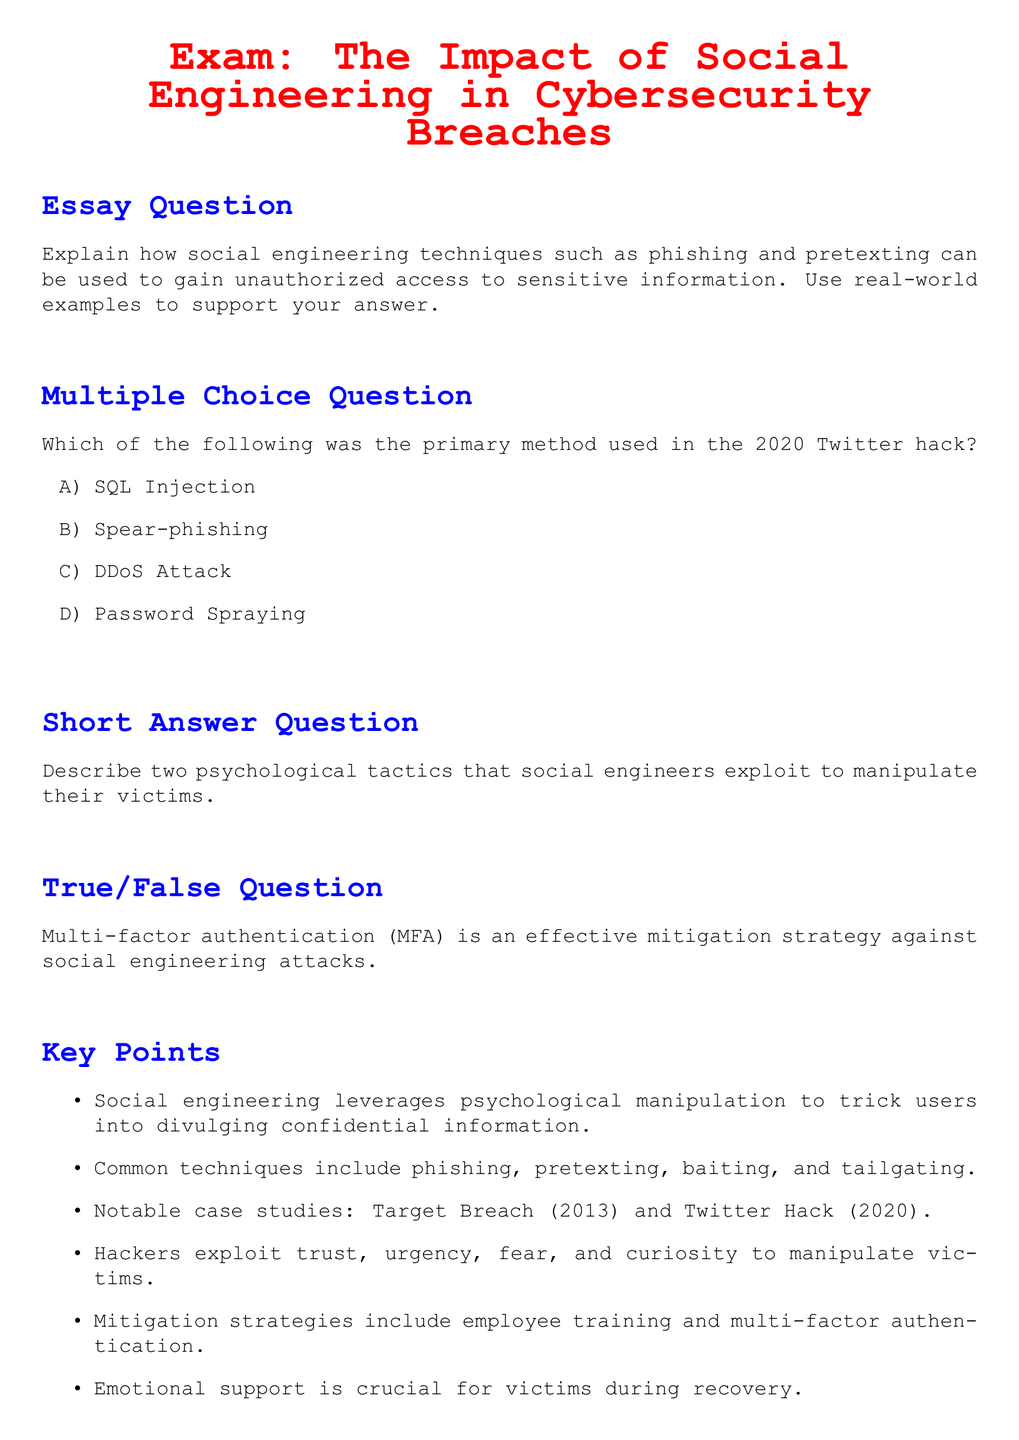What is the title of the exam? The title is prominently displayed at the top of the document.
Answer: Exam: The Impact of Social Engineering in Cybersecurity Breaches What technique is used in the 2020 Twitter hack? This information is found in the multiple choice question section.
Answer: Spear-phishing Name one common technique of social engineering mentioned in the document. Common techniques are listed in the key points section.
Answer: Phishing How many notable case studies are mentioned? The number of notable case studies is clearly stated in the key points section.
Answer: Two True or False: Multi-factor authentication is effective against social engineering attacks. The true/false question section provides this information.
Answer: True What psychological tactic is exploited by social engineers as per the short answer question? This information is sought in the short answer question section requiring explanation of two tactics.
Answer: (Any psychological tactic mentioned in response) 